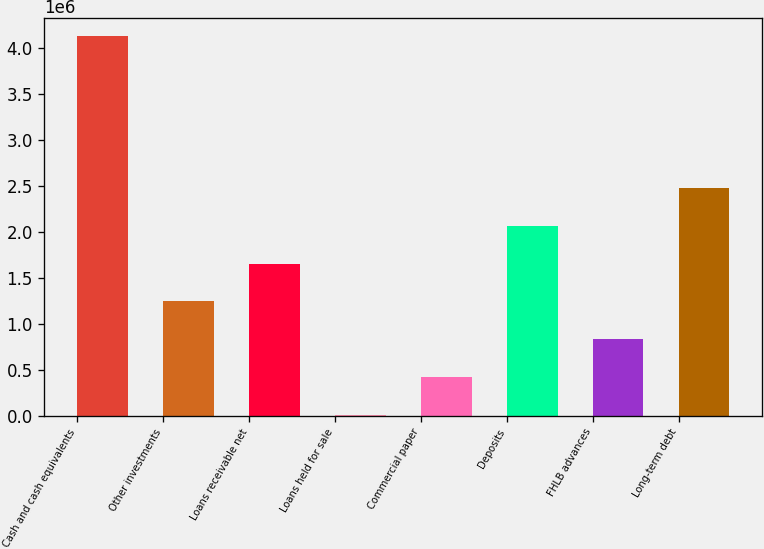Convert chart to OTSL. <chart><loc_0><loc_0><loc_500><loc_500><bar_chart><fcel>Cash and cash equivalents<fcel>Other investments<fcel>Loans receivable net<fcel>Loans held for sale<fcel>Commercial paper<fcel>Deposits<fcel>FHLB advances<fcel>Long-term debt<nl><fcel>4.12372e+06<fcel>1.24233e+06<fcel>1.65396e+06<fcel>7449<fcel>419076<fcel>2.06558e+06<fcel>830702<fcel>2.47721e+06<nl></chart> 